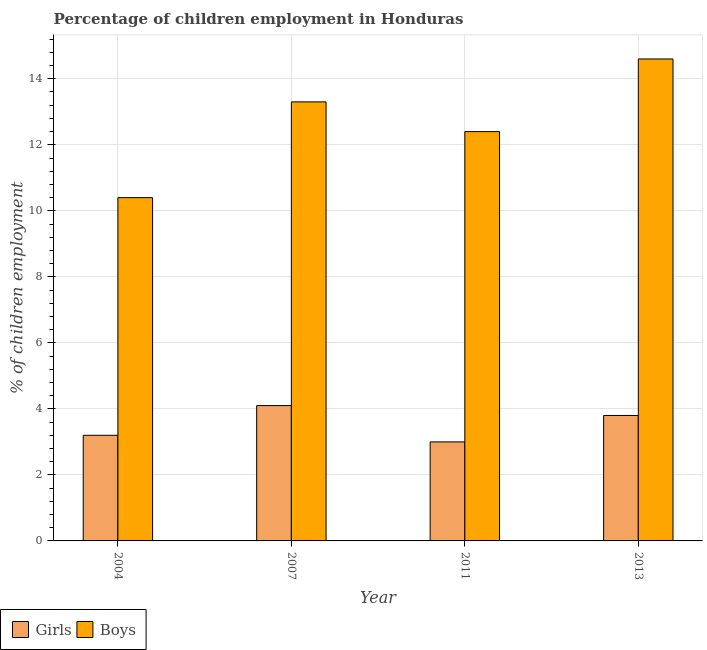How many different coloured bars are there?
Give a very brief answer. 2. Are the number of bars per tick equal to the number of legend labels?
Offer a very short reply. Yes. Are the number of bars on each tick of the X-axis equal?
Your answer should be very brief. Yes. How many bars are there on the 4th tick from the left?
Your response must be concise. 2. What is the percentage of employed girls in 2013?
Your answer should be compact. 3.8. Across all years, what is the maximum percentage of employed boys?
Give a very brief answer. 14.6. Across all years, what is the minimum percentage of employed boys?
Offer a terse response. 10.4. What is the total percentage of employed girls in the graph?
Your response must be concise. 14.1. What is the difference between the percentage of employed girls in 2007 and that in 2011?
Provide a succinct answer. 1.1. What is the difference between the percentage of employed girls in 2011 and the percentage of employed boys in 2004?
Offer a very short reply. -0.2. What is the average percentage of employed boys per year?
Offer a very short reply. 12.68. In the year 2011, what is the difference between the percentage of employed boys and percentage of employed girls?
Provide a succinct answer. 0. What is the ratio of the percentage of employed girls in 2004 to that in 2011?
Offer a very short reply. 1.07. Is the percentage of employed girls in 2004 less than that in 2013?
Your answer should be compact. Yes. What is the difference between the highest and the second highest percentage of employed girls?
Your answer should be very brief. 0.3. What is the difference between the highest and the lowest percentage of employed boys?
Make the answer very short. 4.2. In how many years, is the percentage of employed girls greater than the average percentage of employed girls taken over all years?
Provide a succinct answer. 2. What does the 1st bar from the left in 2004 represents?
Give a very brief answer. Girls. What does the 2nd bar from the right in 2004 represents?
Offer a terse response. Girls. Are all the bars in the graph horizontal?
Your answer should be compact. No. How many years are there in the graph?
Your answer should be very brief. 4. What is the difference between two consecutive major ticks on the Y-axis?
Provide a short and direct response. 2. Are the values on the major ticks of Y-axis written in scientific E-notation?
Make the answer very short. No. Where does the legend appear in the graph?
Your response must be concise. Bottom left. What is the title of the graph?
Make the answer very short. Percentage of children employment in Honduras. Does "Quasi money growth" appear as one of the legend labels in the graph?
Provide a short and direct response. No. What is the label or title of the X-axis?
Your answer should be very brief. Year. What is the label or title of the Y-axis?
Provide a succinct answer. % of children employment. What is the % of children employment of Girls in 2007?
Provide a succinct answer. 4.1. What is the % of children employment of Boys in 2007?
Offer a very short reply. 13.3. What is the % of children employment of Girls in 2011?
Offer a very short reply. 3. What is the % of children employment in Boys in 2011?
Offer a terse response. 12.4. What is the % of children employment of Girls in 2013?
Offer a very short reply. 3.8. What is the % of children employment of Boys in 2013?
Ensure brevity in your answer.  14.6. Across all years, what is the maximum % of children employment in Girls?
Offer a terse response. 4.1. Across all years, what is the maximum % of children employment of Boys?
Your answer should be very brief. 14.6. Across all years, what is the minimum % of children employment in Girls?
Offer a very short reply. 3. Across all years, what is the minimum % of children employment in Boys?
Give a very brief answer. 10.4. What is the total % of children employment in Boys in the graph?
Make the answer very short. 50.7. What is the difference between the % of children employment in Boys in 2004 and that in 2007?
Your answer should be very brief. -2.9. What is the difference between the % of children employment of Boys in 2004 and that in 2013?
Keep it short and to the point. -4.2. What is the difference between the % of children employment of Boys in 2007 and that in 2013?
Your answer should be compact. -1.3. What is the difference between the % of children employment of Boys in 2011 and that in 2013?
Your answer should be very brief. -2.2. What is the difference between the % of children employment in Girls in 2004 and the % of children employment in Boys in 2013?
Provide a short and direct response. -11.4. What is the difference between the % of children employment in Girls in 2007 and the % of children employment in Boys in 2011?
Make the answer very short. -8.3. What is the difference between the % of children employment of Girls in 2011 and the % of children employment of Boys in 2013?
Offer a very short reply. -11.6. What is the average % of children employment in Girls per year?
Offer a very short reply. 3.52. What is the average % of children employment in Boys per year?
Offer a very short reply. 12.68. In the year 2011, what is the difference between the % of children employment of Girls and % of children employment of Boys?
Your answer should be compact. -9.4. In the year 2013, what is the difference between the % of children employment of Girls and % of children employment of Boys?
Provide a succinct answer. -10.8. What is the ratio of the % of children employment of Girls in 2004 to that in 2007?
Offer a terse response. 0.78. What is the ratio of the % of children employment of Boys in 2004 to that in 2007?
Keep it short and to the point. 0.78. What is the ratio of the % of children employment in Girls in 2004 to that in 2011?
Provide a succinct answer. 1.07. What is the ratio of the % of children employment of Boys in 2004 to that in 2011?
Your answer should be very brief. 0.84. What is the ratio of the % of children employment in Girls in 2004 to that in 2013?
Provide a succinct answer. 0.84. What is the ratio of the % of children employment in Boys in 2004 to that in 2013?
Your answer should be compact. 0.71. What is the ratio of the % of children employment of Girls in 2007 to that in 2011?
Offer a very short reply. 1.37. What is the ratio of the % of children employment in Boys in 2007 to that in 2011?
Give a very brief answer. 1.07. What is the ratio of the % of children employment of Girls in 2007 to that in 2013?
Offer a terse response. 1.08. What is the ratio of the % of children employment of Boys in 2007 to that in 2013?
Your answer should be compact. 0.91. What is the ratio of the % of children employment in Girls in 2011 to that in 2013?
Make the answer very short. 0.79. What is the ratio of the % of children employment of Boys in 2011 to that in 2013?
Keep it short and to the point. 0.85. What is the difference between the highest and the second highest % of children employment of Boys?
Provide a short and direct response. 1.3. What is the difference between the highest and the lowest % of children employment in Girls?
Your response must be concise. 1.1. 